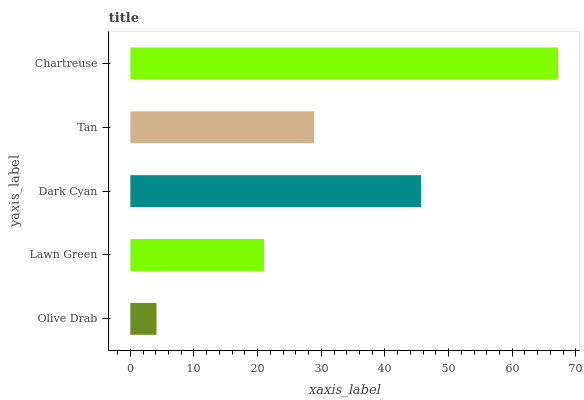Is Olive Drab the minimum?
Answer yes or no. Yes. Is Chartreuse the maximum?
Answer yes or no. Yes. Is Lawn Green the minimum?
Answer yes or no. No. Is Lawn Green the maximum?
Answer yes or no. No. Is Lawn Green greater than Olive Drab?
Answer yes or no. Yes. Is Olive Drab less than Lawn Green?
Answer yes or no. Yes. Is Olive Drab greater than Lawn Green?
Answer yes or no. No. Is Lawn Green less than Olive Drab?
Answer yes or no. No. Is Tan the high median?
Answer yes or no. Yes. Is Tan the low median?
Answer yes or no. Yes. Is Olive Drab the high median?
Answer yes or no. No. Is Chartreuse the low median?
Answer yes or no. No. 